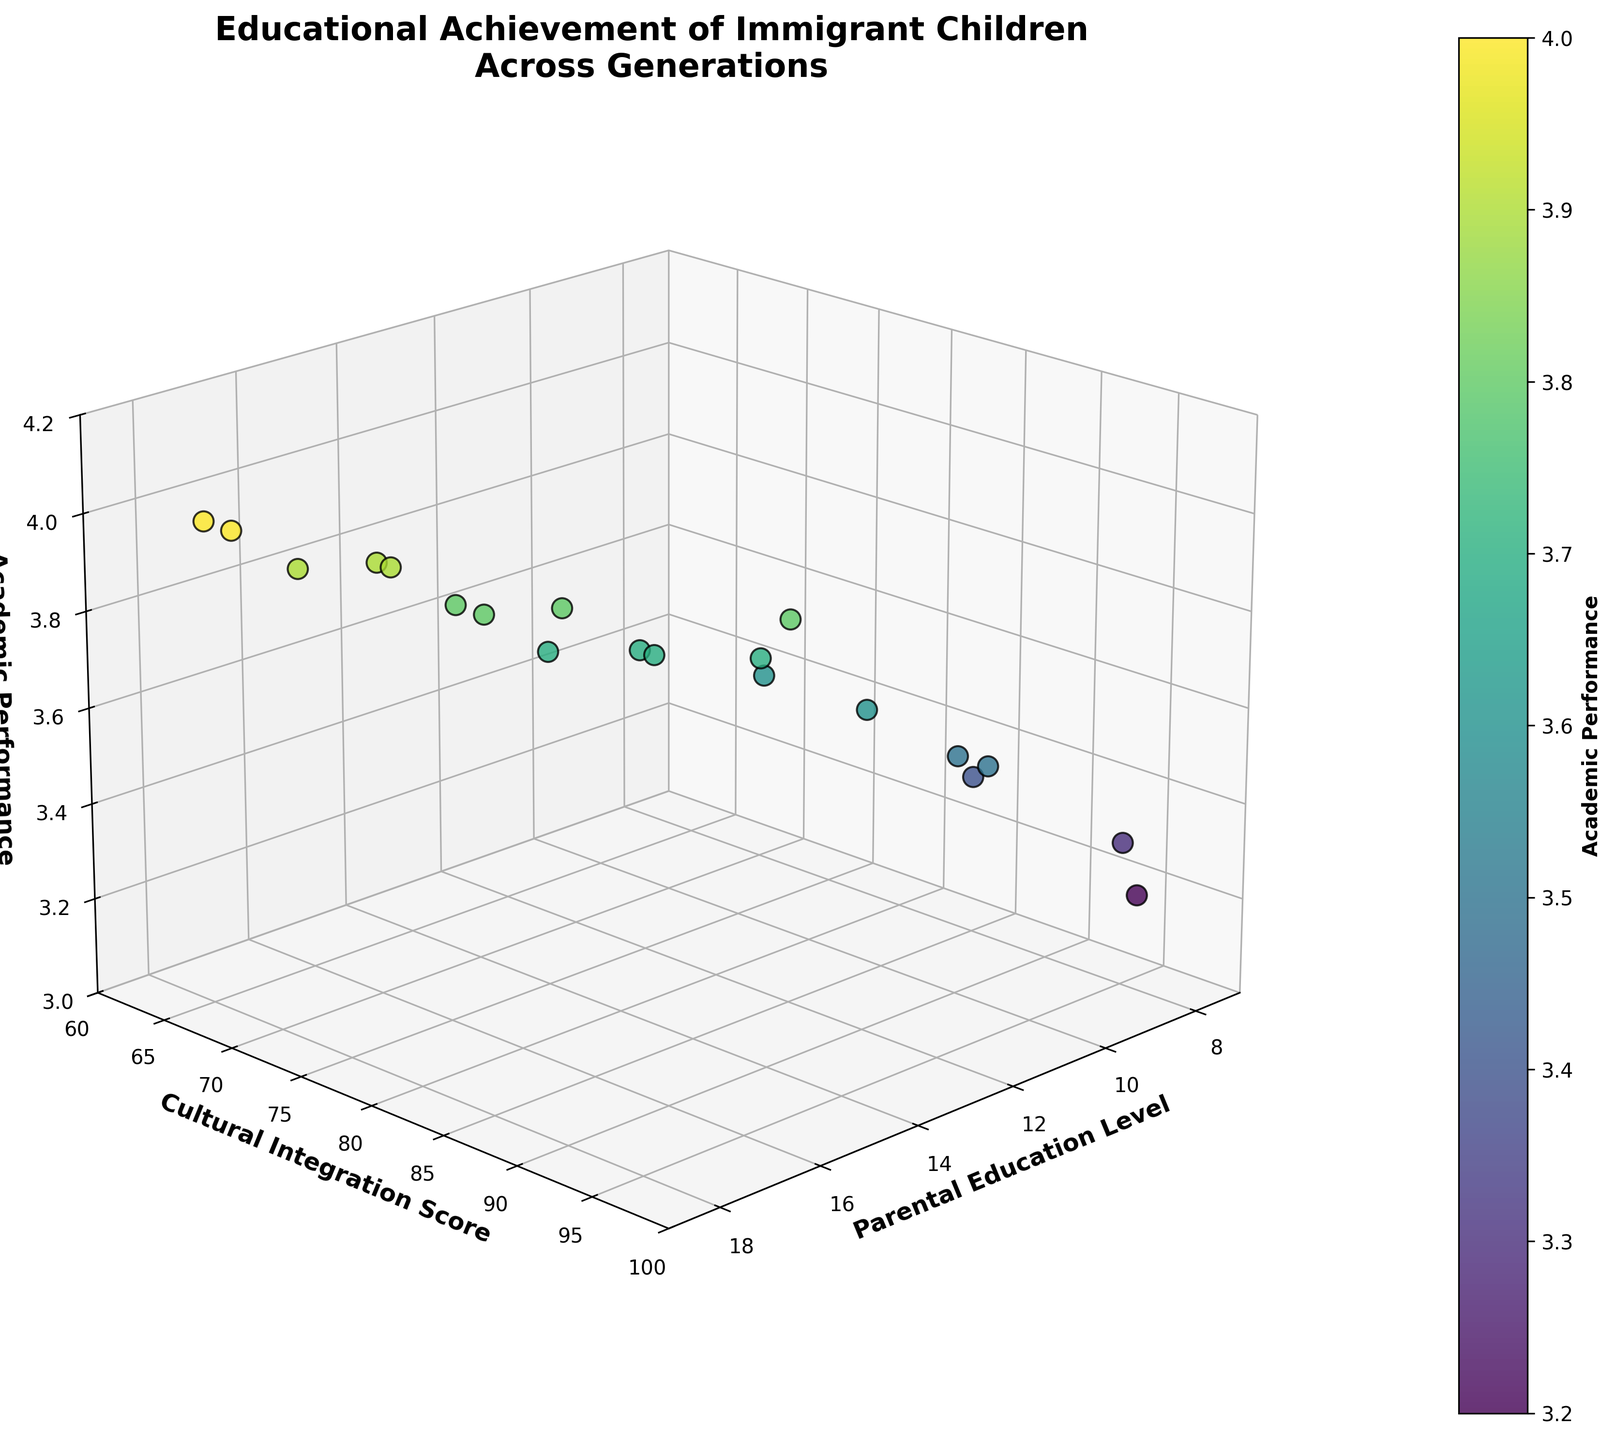What are the axes labels on the figure? The axis labels are visible on the sides of the plot. The x-axis is labeled "Parental Education Level," the y-axis is labeled "Cultural Integration Score," and the z-axis is labeled "Academic Performance."
Answer: "Parental Education Level," "Cultural Integration Score," "Academic Performance" What is the title of the plot? The title is displayed at the top of the figure. It reads "Educational Achievement of Immigrant Children Across Generations."
Answer: Educational Achievement of Immigrant Children Across Generations How many data points are plotted in the figure? By counting the plotted points in the 3D scatter plot, you can see there are 20 data points.
Answer: 20 Which data point has the highest academic performance and what are its parental education level and cultural integration score? The highest academic performance is at 4.0. There are two points with this value: one at parental education level 18 with cultural integration score 65, and another at parental education level 18 with cultural integration score 67.
Answer: (18, 65) and (18, 67) What is the range of the z-axis (Academic Performance)? The z-axis range is shown by the tick marks along the axis, which span from 3.0 to 4.2.
Answer: 3.0 to 4.2 How does academic performance generally relate to parental education level? By examining the positioning and color shading of points along the x-axis (Parental Education Level) and z-axis (Academic Performance), it appears that higher parental education levels are often associated with higher academic performance.
Answer: Higher parental education levels are associated with higher academic performance What is the average academic performance score for points where the cultural integration score is above 80? Identifying the points with a cultural integration score greater than 80 and averaging their academic performance scores: Points: (85, 3.8), (90, 3.5), (95, 3.3), (88, 3.4), (92, 3.5), (96, 3.2), (87, 3.6). Sum: 3.8 + 3.5 + 3.3 + 3.4 + 3.5 + 3.2 + 3.6 = 24.3. Average: 24.3 / 7 = 3.47
Answer: 3.47 What are the highest and lowest cultural integration scores? The highest cultural integration score is 96, and the lowest is 60, as indicated by the range of the y-axis.
Answer: 96 and 60 Which data point has the lowest academic performance and what are its parental education level and cultural integration score? The lowest academic performance is at 3.2. The corresponding point has a parental education level of 8 and a cultural integration score of 96.
Answer: (8, 96) Is there a visible trend between cultural integration score and academic performance? Observing the spread and color of points along the y-axis (Cultural Integration Score) and z-axis (Academic Performance), it is difficult to see a strong trend because points with high and low cultural integration scores have varied academic performances.
Answer: No strong visible trend 